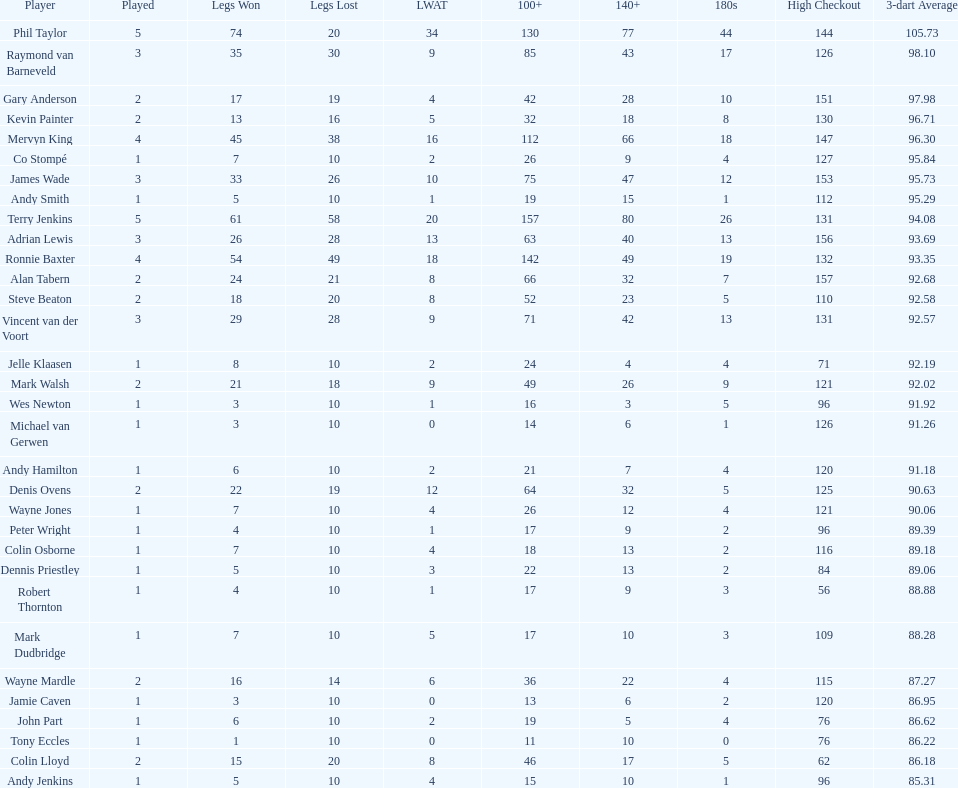List each of the players with a high checkout of 131. Terry Jenkins, Vincent van der Voort. 